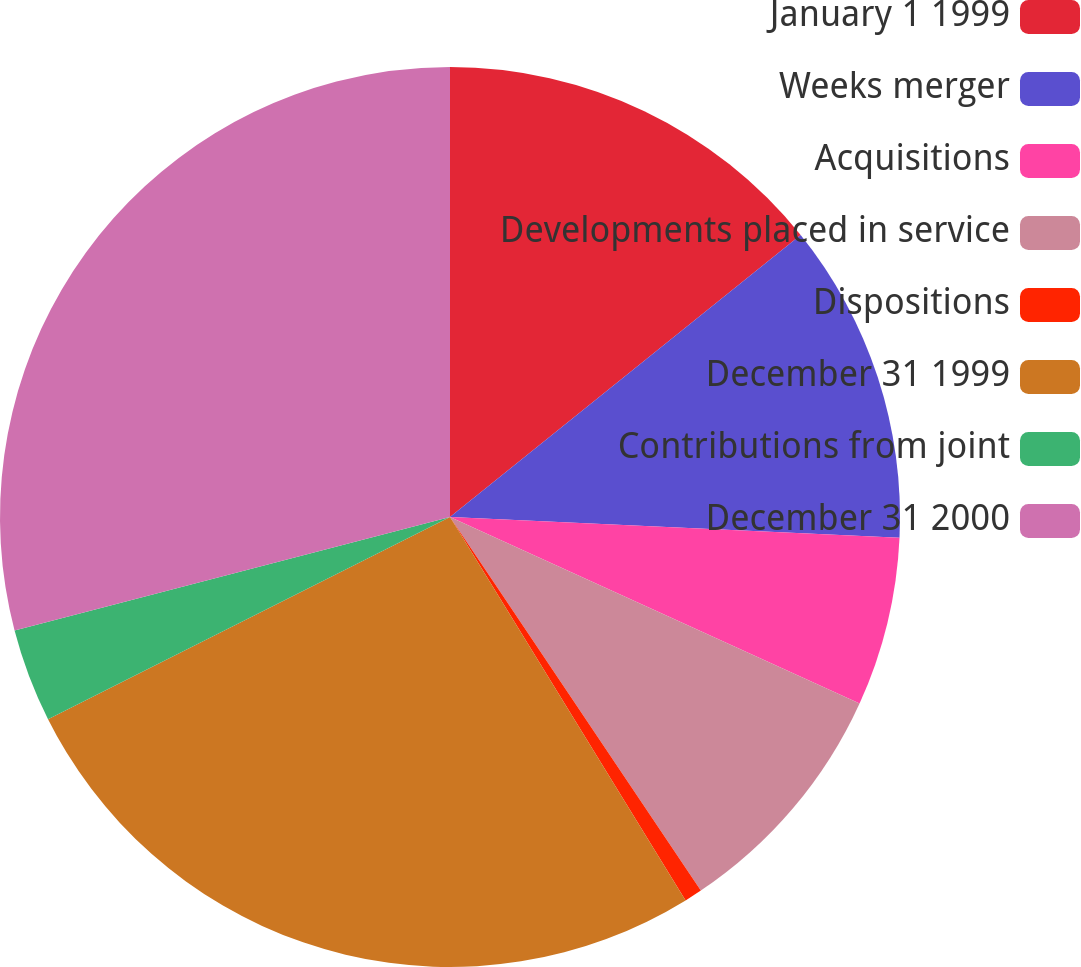Convert chart. <chart><loc_0><loc_0><loc_500><loc_500><pie_chart><fcel>January 1 1999<fcel>Weeks merger<fcel>Acquisitions<fcel>Developments placed in service<fcel>Dispositions<fcel>December 31 1999<fcel>Contributions from joint<fcel>December 31 2000<nl><fcel>14.22%<fcel>11.51%<fcel>6.07%<fcel>8.79%<fcel>0.64%<fcel>26.35%<fcel>3.36%<fcel>29.06%<nl></chart> 